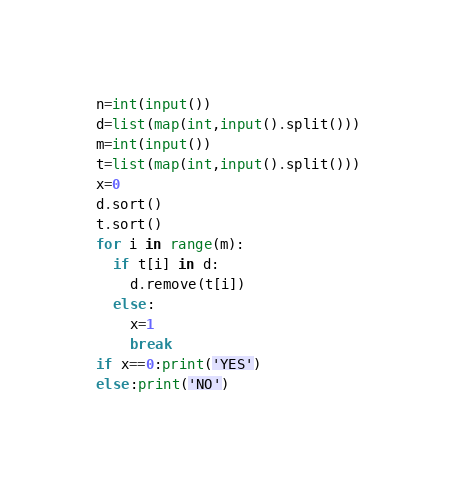<code> <loc_0><loc_0><loc_500><loc_500><_Python_>n=int(input())
d=list(map(int,input().split()))
m=int(input())
t=list(map(int,input().split()))
x=0
d.sort()
t.sort()
for i in range(m):
  if t[i] in d:
    d.remove(t[i])
  else:
    x=1
    break
if x==0:print('YES')
else:print('NO')</code> 